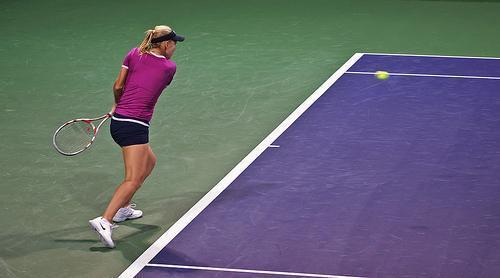How many people are playing football?
Give a very brief answer. 0. 